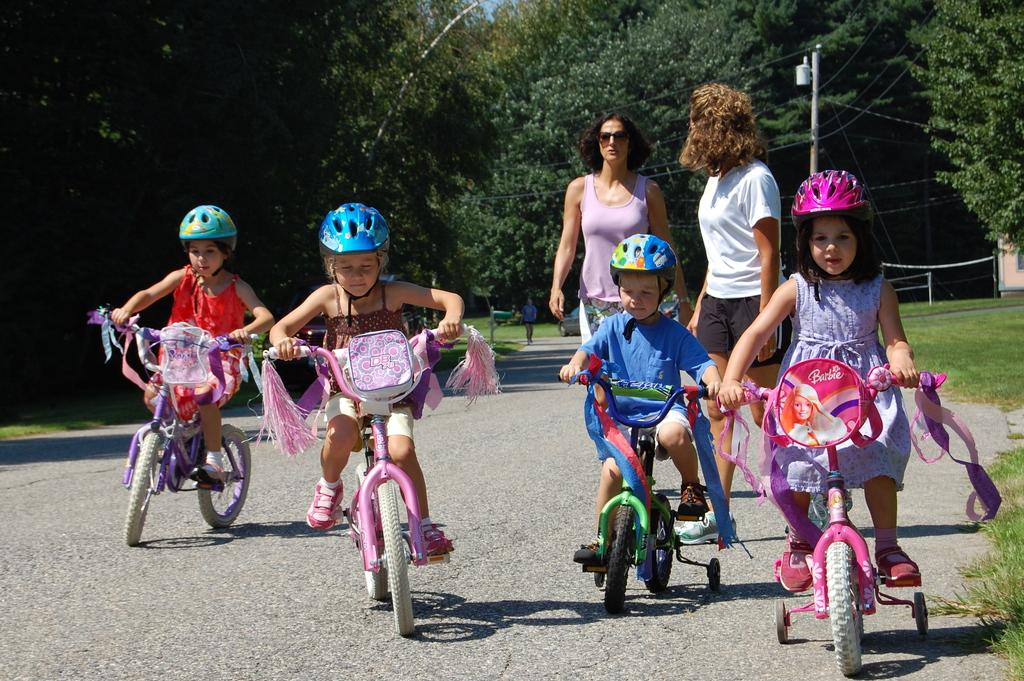How many children are in the image? There are 4 children in the image. What are the children doing in the image? The children are on a cycle. Who is present in the background of the image? There are 2 women, a pole, a car, and a person in the background of the image. What can be seen in the background of the image? There are trees and a path in the background of the image. What type of zebra can be seen in the bedroom in the image? There is no zebra or bedroom present in the image. Is there an arch visible in the image? There is no arch visible in the image. 